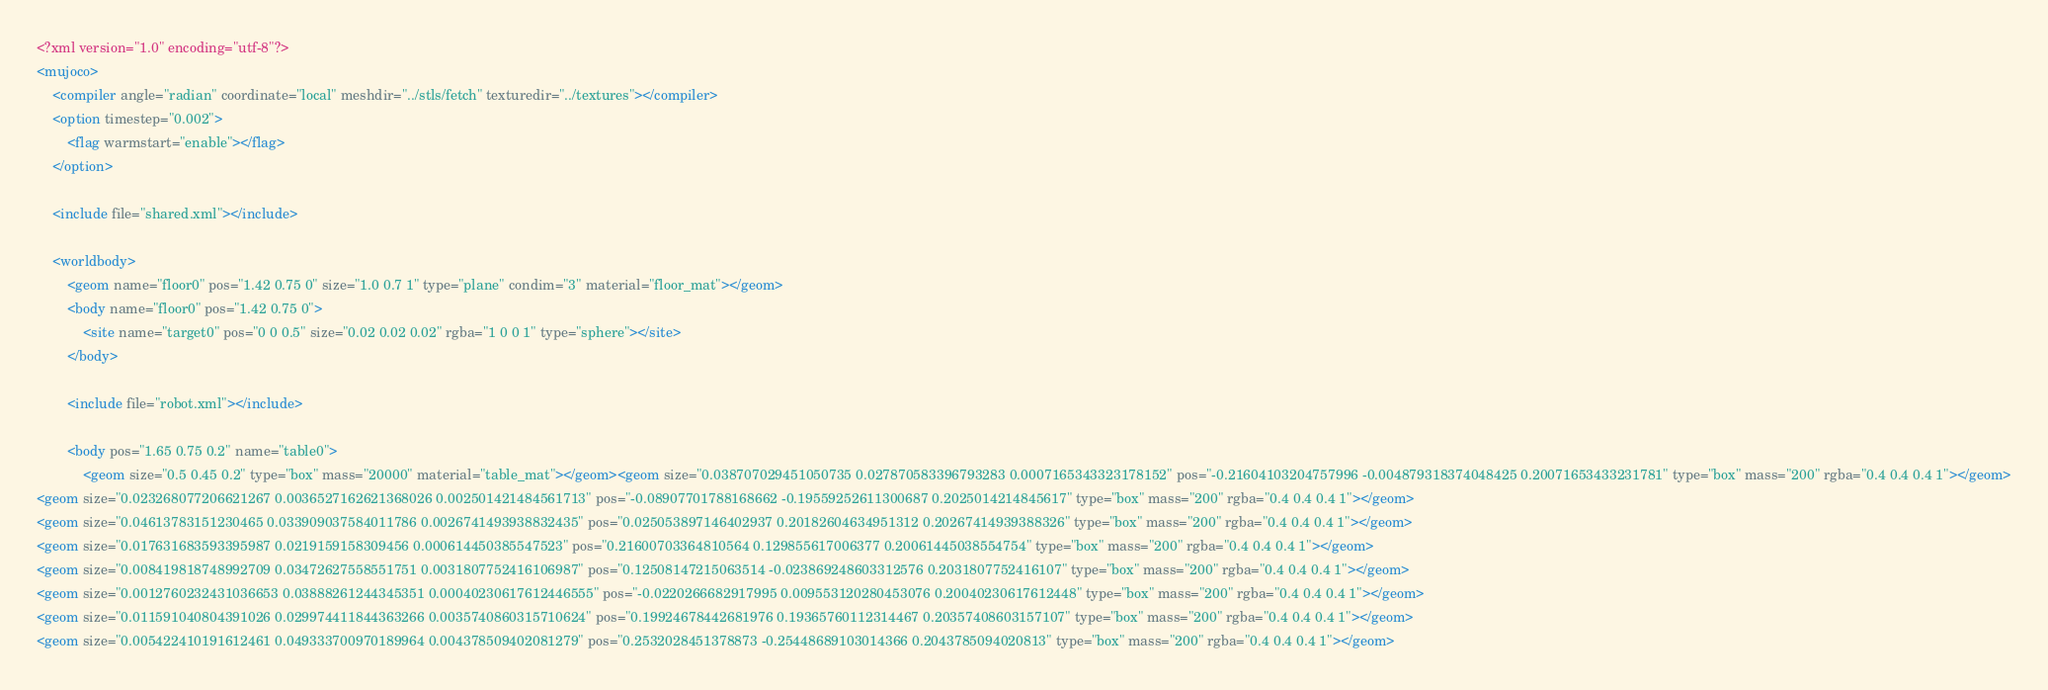<code> <loc_0><loc_0><loc_500><loc_500><_XML_><?xml version="1.0" encoding="utf-8"?>
<mujoco>
    <compiler angle="radian" coordinate="local" meshdir="../stls/fetch" texturedir="../textures"></compiler>
    <option timestep="0.002">
        <flag warmstart="enable"></flag>
    </option>

    <include file="shared.xml"></include>
    
    <worldbody>
        <geom name="floor0" pos="1.42 0.75 0" size="1.0 0.7 1" type="plane" condim="3" material="floor_mat"></geom>
        <body name="floor0" pos="1.42 0.75 0">
            <site name="target0" pos="0 0 0.5" size="0.02 0.02 0.02" rgba="1 0 0 1" type="sphere"></site>
        </body>

        <include file="robot.xml"></include>
        
        <body pos="1.65 0.75 0.2" name="table0">
            <geom size="0.5 0.45 0.2" type="box" mass="20000" material="table_mat"></geom><geom size="0.038707029451050735 0.027870583396793283 0.0007165343323178152" pos="-0.21604103204757996 -0.004879318374048425 0.20071653433231781" type="box" mass="200" rgba="0.4 0.4 0.4 1"></geom>
<geom size="0.023268077206621267 0.0036527162621368026 0.002501421484561713" pos="-0.08907701788168662 -0.19559252611300687 0.2025014214845617" type="box" mass="200" rgba="0.4 0.4 0.4 1"></geom>
<geom size="0.04613783151230465 0.033909037584011786 0.0026741493938832435" pos="0.025053897146402937 0.20182604634951312 0.20267414939388326" type="box" mass="200" rgba="0.4 0.4 0.4 1"></geom>
<geom size="0.017631683593395987 0.0219159158309456 0.000614450385547523" pos="0.21600703364810564 0.129855617006377 0.20061445038554754" type="box" mass="200" rgba="0.4 0.4 0.4 1"></geom>
<geom size="0.008419818748992709 0.03472627558551751 0.0031807752416106987" pos="0.12508147215063514 -0.023869248603312576 0.2031807752416107" type="box" mass="200" rgba="0.4 0.4 0.4 1"></geom>
<geom size="0.0012760232431036653 0.03888261244345351 0.00040230617612446555" pos="-0.0220266682917995 0.009553120280453076 0.20040230617612448" type="box" mass="200" rgba="0.4 0.4 0.4 1"></geom>
<geom size="0.011591040804391026 0.029974411844363266 0.0035740860315710624" pos="0.19924678442681976 0.19365760112314467 0.20357408603157107" type="box" mass="200" rgba="0.4 0.4 0.4 1"></geom>
<geom size="0.005422410191612461 0.049333700970189964 0.004378509402081279" pos="0.2532028451378873 -0.25448689103014366 0.2043785094020813" type="box" mass="200" rgba="0.4 0.4 0.4 1"></geom></code> 